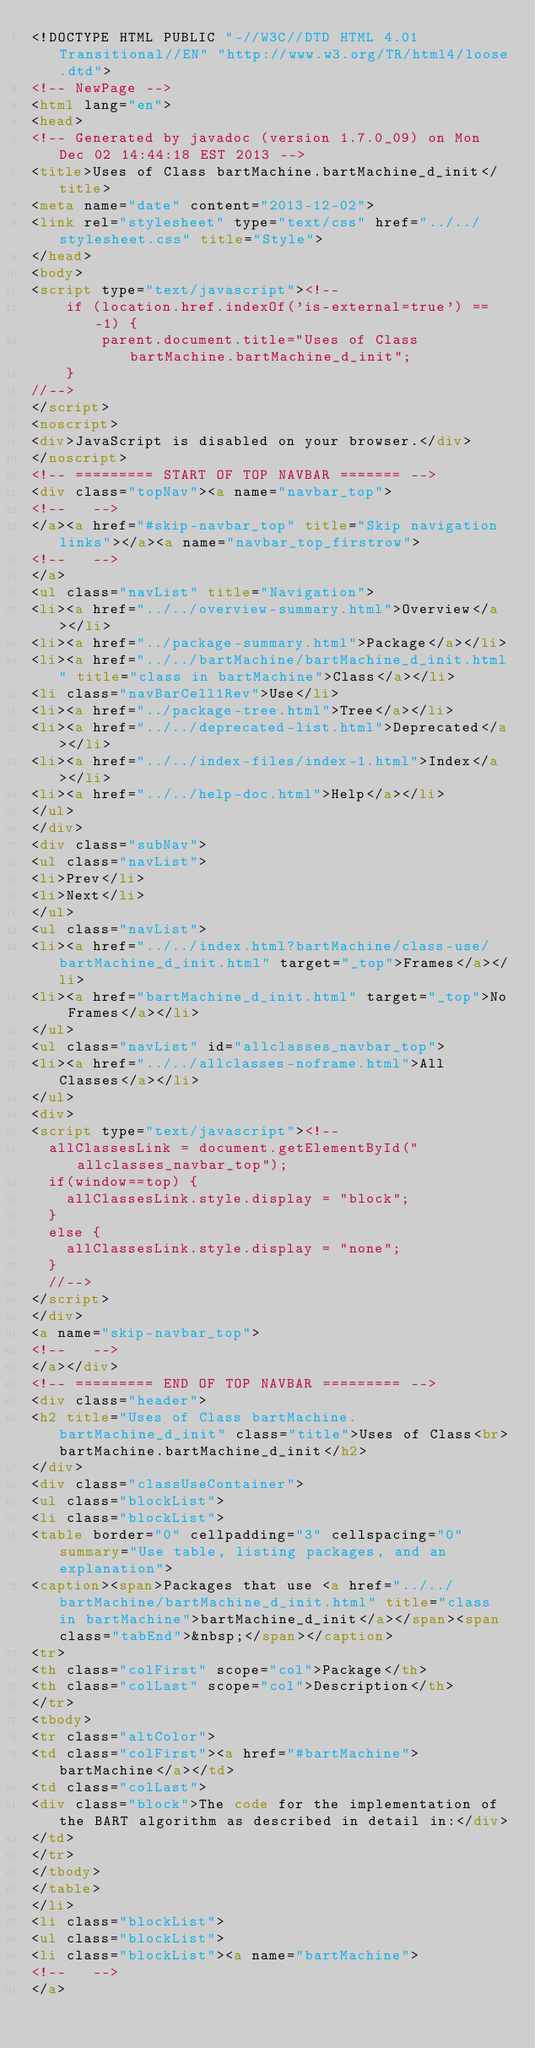<code> <loc_0><loc_0><loc_500><loc_500><_HTML_><!DOCTYPE HTML PUBLIC "-//W3C//DTD HTML 4.01 Transitional//EN" "http://www.w3.org/TR/html4/loose.dtd">
<!-- NewPage -->
<html lang="en">
<head>
<!-- Generated by javadoc (version 1.7.0_09) on Mon Dec 02 14:44:18 EST 2013 -->
<title>Uses of Class bartMachine.bartMachine_d_init</title>
<meta name="date" content="2013-12-02">
<link rel="stylesheet" type="text/css" href="../../stylesheet.css" title="Style">
</head>
<body>
<script type="text/javascript"><!--
    if (location.href.indexOf('is-external=true') == -1) {
        parent.document.title="Uses of Class bartMachine.bartMachine_d_init";
    }
//-->
</script>
<noscript>
<div>JavaScript is disabled on your browser.</div>
</noscript>
<!-- ========= START OF TOP NAVBAR ======= -->
<div class="topNav"><a name="navbar_top">
<!--   -->
</a><a href="#skip-navbar_top" title="Skip navigation links"></a><a name="navbar_top_firstrow">
<!--   -->
</a>
<ul class="navList" title="Navigation">
<li><a href="../../overview-summary.html">Overview</a></li>
<li><a href="../package-summary.html">Package</a></li>
<li><a href="../../bartMachine/bartMachine_d_init.html" title="class in bartMachine">Class</a></li>
<li class="navBarCell1Rev">Use</li>
<li><a href="../package-tree.html">Tree</a></li>
<li><a href="../../deprecated-list.html">Deprecated</a></li>
<li><a href="../../index-files/index-1.html">Index</a></li>
<li><a href="../../help-doc.html">Help</a></li>
</ul>
</div>
<div class="subNav">
<ul class="navList">
<li>Prev</li>
<li>Next</li>
</ul>
<ul class="navList">
<li><a href="../../index.html?bartMachine/class-use/bartMachine_d_init.html" target="_top">Frames</a></li>
<li><a href="bartMachine_d_init.html" target="_top">No Frames</a></li>
</ul>
<ul class="navList" id="allclasses_navbar_top">
<li><a href="../../allclasses-noframe.html">All Classes</a></li>
</ul>
<div>
<script type="text/javascript"><!--
  allClassesLink = document.getElementById("allclasses_navbar_top");
  if(window==top) {
    allClassesLink.style.display = "block";
  }
  else {
    allClassesLink.style.display = "none";
  }
  //-->
</script>
</div>
<a name="skip-navbar_top">
<!--   -->
</a></div>
<!-- ========= END OF TOP NAVBAR ========= -->
<div class="header">
<h2 title="Uses of Class bartMachine.bartMachine_d_init" class="title">Uses of Class<br>bartMachine.bartMachine_d_init</h2>
</div>
<div class="classUseContainer">
<ul class="blockList">
<li class="blockList">
<table border="0" cellpadding="3" cellspacing="0" summary="Use table, listing packages, and an explanation">
<caption><span>Packages that use <a href="../../bartMachine/bartMachine_d_init.html" title="class in bartMachine">bartMachine_d_init</a></span><span class="tabEnd">&nbsp;</span></caption>
<tr>
<th class="colFirst" scope="col">Package</th>
<th class="colLast" scope="col">Description</th>
</tr>
<tbody>
<tr class="altColor">
<td class="colFirst"><a href="#bartMachine">bartMachine</a></td>
<td class="colLast">
<div class="block">The code for the implementation of the BART algorithm as described in detail in:</div>
</td>
</tr>
</tbody>
</table>
</li>
<li class="blockList">
<ul class="blockList">
<li class="blockList"><a name="bartMachine">
<!--   -->
</a></code> 